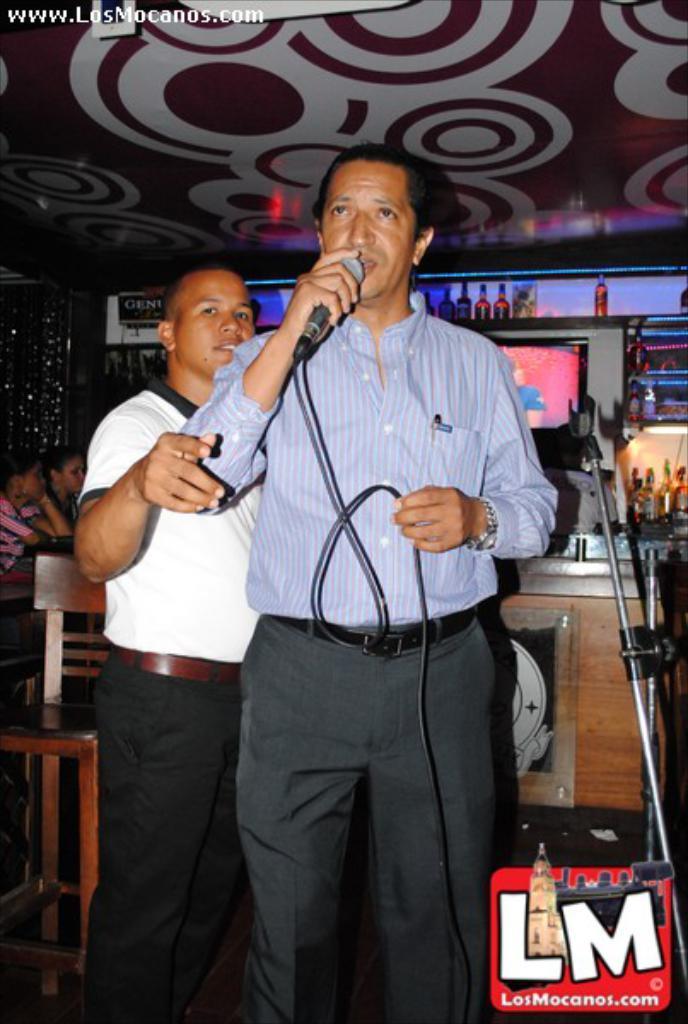Could you give a brief overview of what you see in this image? In this image we can see two people standing in which one of them holding microphone, behind him there are chairs, table and other things. 